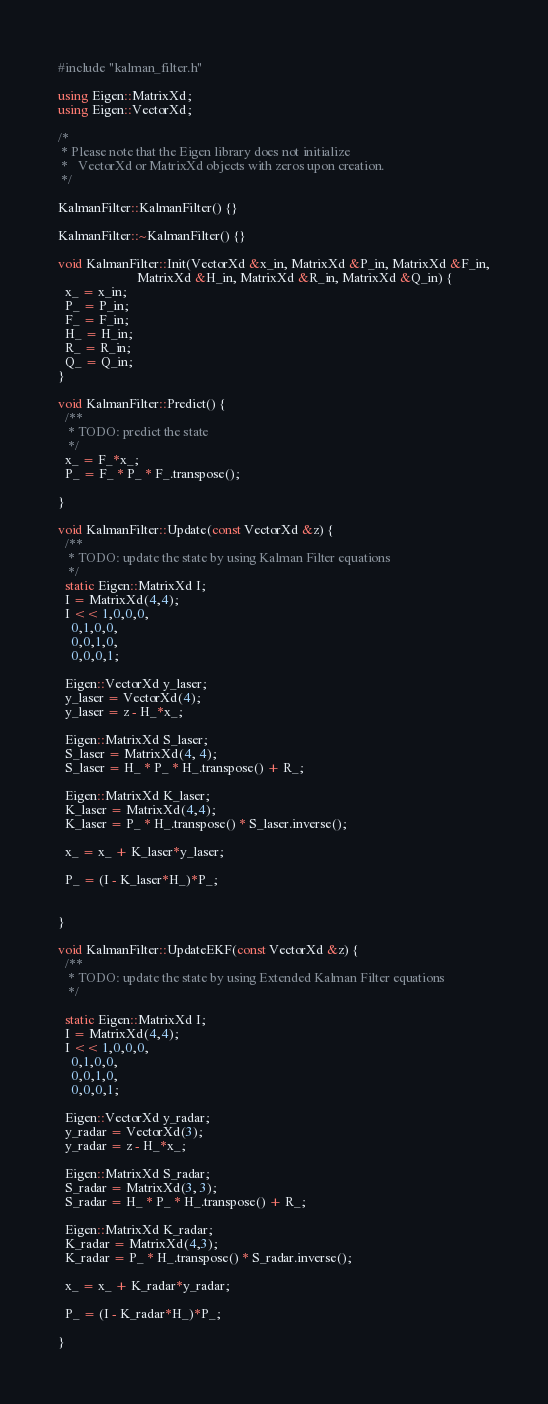Convert code to text. <code><loc_0><loc_0><loc_500><loc_500><_C++_>#include "kalman_filter.h"

using Eigen::MatrixXd;
using Eigen::VectorXd;

/* 
 * Please note that the Eigen library does not initialize 
 *   VectorXd or MatrixXd objects with zeros upon creation.
 */

KalmanFilter::KalmanFilter() {}

KalmanFilter::~KalmanFilter() {}

void KalmanFilter::Init(VectorXd &x_in, MatrixXd &P_in, MatrixXd &F_in,
                        MatrixXd &H_in, MatrixXd &R_in, MatrixXd &Q_in) {
  x_ = x_in;
  P_ = P_in;
  F_ = F_in;
  H_ = H_in;
  R_ = R_in;
  Q_ = Q_in;
}

void KalmanFilter::Predict() {
  /**
   * TODO: predict the state
   */
  x_ = F_*x_;
  P_ = F_ * P_ * F_.transpose();

}

void KalmanFilter::Update(const VectorXd &z) {
  /**
   * TODO: update the state by using Kalman Filter equations
   */
  static Eigen::MatrixXd I;
  I = MatrixXd(4,4);
  I << 1,0,0,0,
    0,1,0,0,
    0,0,1,0,
    0,0,0,1;

  Eigen::VectorXd y_laser;
  y_laser = VectorXd(4);
  y_laser = z - H_*x_;

  Eigen::MatrixXd S_laser;
  S_laser = MatrixXd(4, 4);
  S_laser = H_ * P_ * H_.transpose() + R_;
  
  Eigen::MatrixXd K_laser;
  K_laser = MatrixXd(4,4);
  K_laser = P_ * H_.transpose() * S_laser.inverse();

  x_ = x_ + K_laser*y_laser;
  
  P_ = (I - K_laser*H_)*P_;


}

void KalmanFilter::UpdateEKF(const VectorXd &z) {
  /**
   * TODO: update the state by using Extended Kalman Filter equations
   */

  static Eigen::MatrixXd I;
  I = MatrixXd(4,4);
  I << 1,0,0,0,
    0,1,0,0,
    0,0,1,0,
    0,0,0,1;

  Eigen::VectorXd y_radar;
  y_radar = VectorXd(3);
  y_radar = z - H_*x_;

  Eigen::MatrixXd S_radar;
  S_radar = MatrixXd(3, 3);
  S_radar = H_ * P_ * H_.transpose() + R_;
  
  Eigen::MatrixXd K_radar;
  K_radar = MatrixXd(4,3);
  K_radar = P_ * H_.transpose() * S_radar.inverse();

  x_ = x_ + K_radar*y_radar;
  
  P_ = (I - K_radar*H_)*P_;

}
</code> 